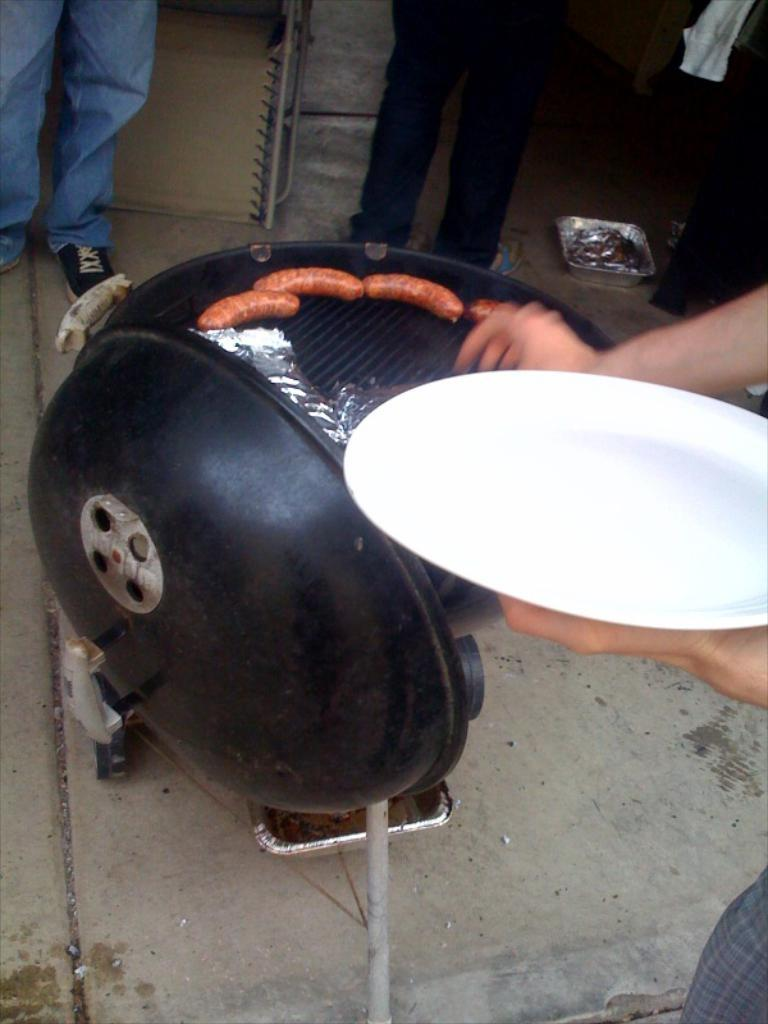What is being held by the person's hand in the image? There is a person's hand holding a white plate in the image. What can be seen cooking or being prepared in the image? There is a barbecue grill in the image. Whose legs are visible in the image? Two people's legs are visible in the image. What type of structure can be seen in the image? There is a wall in the image. What type of ink is being used to create a rhythm in the image? There is no ink or rhythm present in the image; it features a person's hand holding a plate, a barbecue grill, two people's legs, and a wall. Is there a battle taking place in the image? No, there is no battle present in the image. 